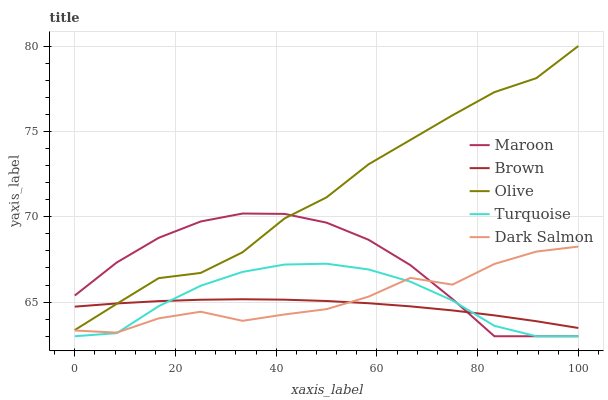Does Turquoise have the minimum area under the curve?
Answer yes or no. No. Does Turquoise have the maximum area under the curve?
Answer yes or no. No. Is Turquoise the smoothest?
Answer yes or no. No. Is Turquoise the roughest?
Answer yes or no. No. Does Brown have the lowest value?
Answer yes or no. No. Does Turquoise have the highest value?
Answer yes or no. No. Is Dark Salmon less than Olive?
Answer yes or no. Yes. Is Olive greater than Turquoise?
Answer yes or no. Yes. Does Dark Salmon intersect Olive?
Answer yes or no. No. 